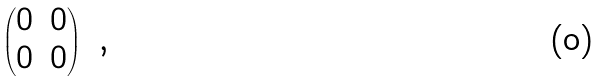Convert formula to latex. <formula><loc_0><loc_0><loc_500><loc_500>\begin{pmatrix} 0 & 0 \\ 0 & 0 \end{pmatrix} \ ,</formula> 